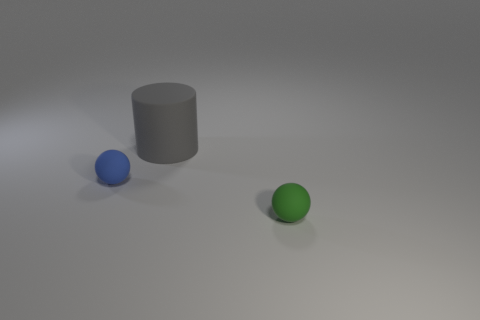Are there fewer tiny spheres on the right side of the green matte object than tiny matte balls in front of the tiny blue ball?
Your answer should be very brief. Yes. What number of brown spheres are there?
Offer a terse response. 0. The tiny ball that is to the left of the small green matte thing is what color?
Provide a short and direct response. Blue. How big is the green object?
Provide a succinct answer. Small. What color is the tiny rubber object behind the object that is in front of the blue matte thing?
Offer a terse response. Blue. Are there any other things that have the same size as the gray rubber object?
Offer a very short reply. No. There is a object left of the large rubber object; does it have the same shape as the big matte object?
Keep it short and to the point. No. What number of matte things are behind the tiny green rubber ball and in front of the big gray rubber cylinder?
Provide a short and direct response. 1. What color is the sphere left of the small sphere right of the ball that is on the left side of the small green thing?
Make the answer very short. Blue. There is a thing right of the big rubber cylinder; what number of cylinders are in front of it?
Ensure brevity in your answer.  0. 